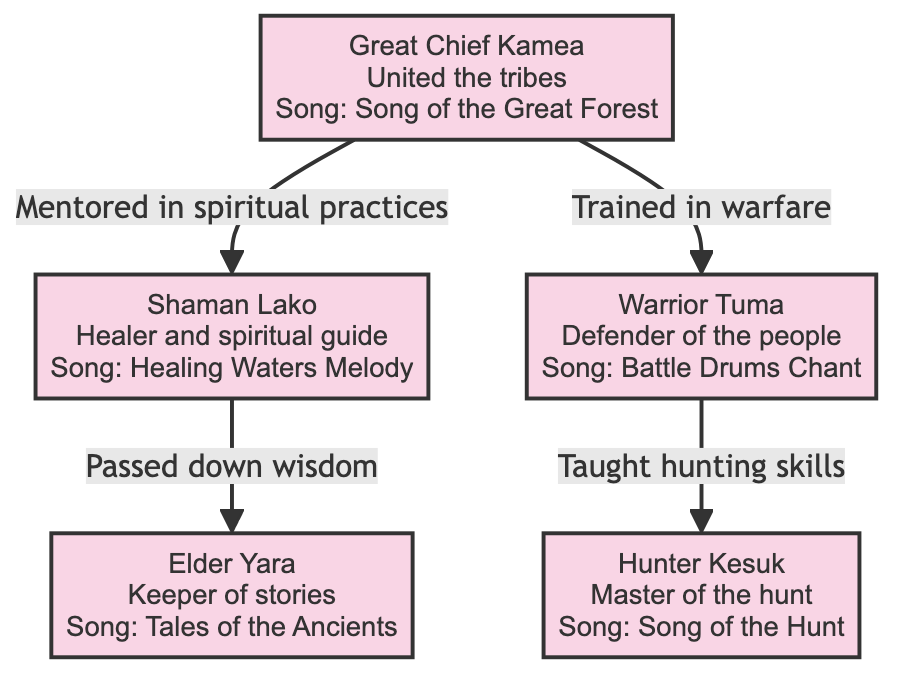What is the title of the song associated with Great Chief Kamea? The diagram indicates that Great Chief Kamea is associated with the song "Song of the Great Forest." This is highlighted directly within the node for Great Chief Kamea.
Answer: Song of the Great Forest How many ancestors are represented in the diagram? By counting the ancestor nodes in the diagram, we find that there are a total of five ancestors represented: Great Chief Kamea, Shaman Lako, Warrior Tuma, Elder Yara, and Hunter Kesuk.
Answer: 5 Which ancestor is connected to both the Warrior Tuma and Hunter Kesuk? The diagram shows that Warrior Tuma receives hunting skills from Great Chief Kamea, while Hunter Kesuk is trained in hunting by Warrior Tuma. Thus, the connection to both is made through Warrior Tuma.
Answer: Warrior Tuma What kind of wisdom did Shaman Lako pass down? According to the diagram, Shaman Lako, who is a healer and spiritual guide, passed down wisdom to Elder Yara, the keeper of stories. The relationship is depicted explicitly through the connecting arrow that notes "Passed down wisdom."
Answer: Wisdom Who mentored Shaman Lako in spiritual practices? The diagram shows that Great Chief Kamea is the ancestor who mentored Shaman Lako in spiritual practices, as indicated by the connecting line and label "Mentored in spiritual practices."
Answer: Great Chief Kamea What role does Elder Yara have within the ancestors? Within the diagram, Elder Yara is characterized as the "Keeper of stories." This is stated directly in the node for Elder Yara and describes their significant role among the relatives.
Answer: Keeper of stories Which ancestor is described as a defender of the people? The node for Warrior Tuma explicitly states his description as "Defender of the people," making it clear what role this ancestor holds within the genealogical tree.
Answer: Warrior Tuma What is the song associated with Shaman Lako? The diagram directly associates Shaman Lako with the song "Healing Waters Melody," clearly listed within that ancestor's node.
Answer: Healing Waters Melody 